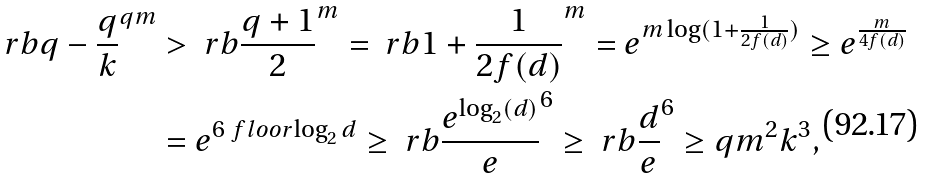Convert formula to latex. <formula><loc_0><loc_0><loc_500><loc_500>\ r b { q - \frac { q } { k } } ^ { q m } & > \ r b { \frac { q + 1 } { 2 } } ^ { m } = \ r b { 1 + \frac { 1 } { 2 f ( d ) } } ^ { m } = e ^ { m \log ( 1 + \frac { 1 } { 2 f ( d ) } ) } \geq e ^ { \frac { m } { 4 f ( d ) } } \\ & = e ^ { 6 \ f l o o r { \log _ { 2 } d } } \geq \ r b { \frac { e ^ { \log _ { 2 } ( d ) } } { e } } ^ { 6 } \geq \ r b { \frac { d } { e } } ^ { 6 } \geq q m ^ { 2 } k ^ { 3 } ,</formula> 